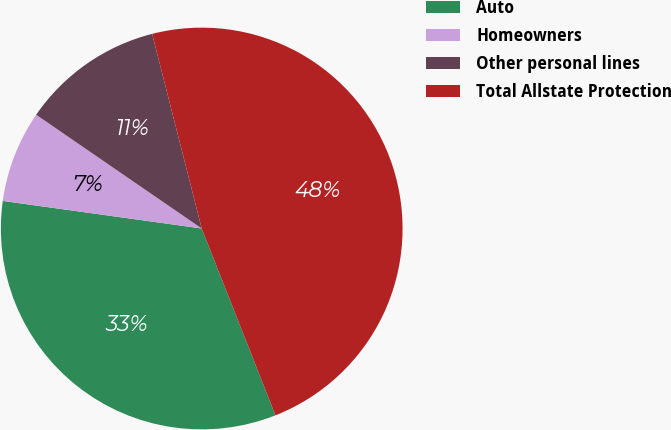<chart> <loc_0><loc_0><loc_500><loc_500><pie_chart><fcel>Auto<fcel>Homeowners<fcel>Other personal lines<fcel>Total Allstate Protection<nl><fcel>33.18%<fcel>7.39%<fcel>11.45%<fcel>47.99%<nl></chart> 